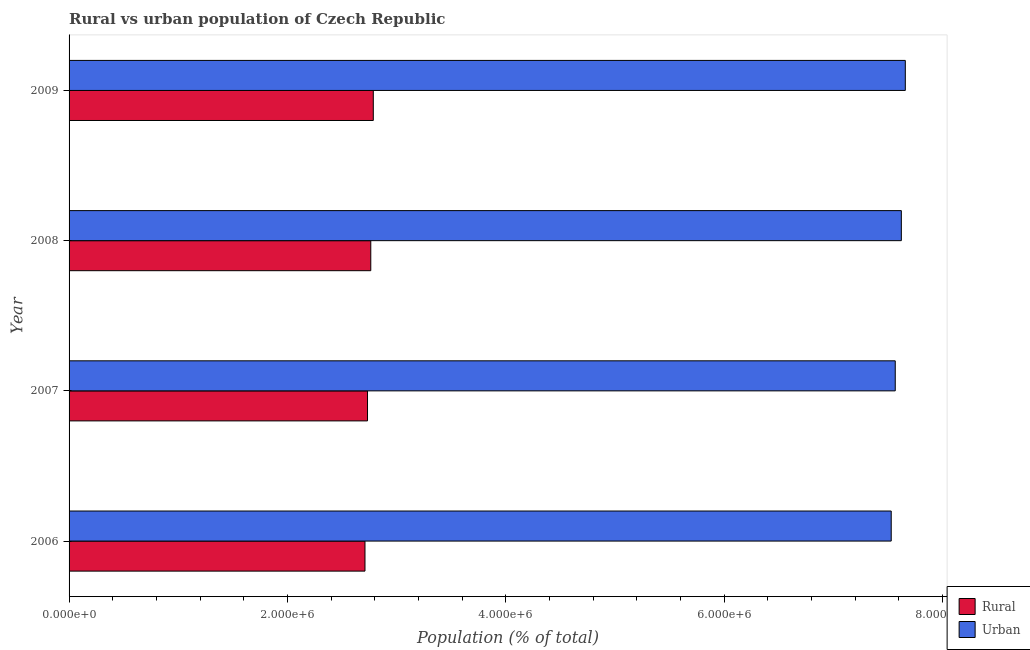How many groups of bars are there?
Provide a succinct answer. 4. How many bars are there on the 4th tick from the top?
Give a very brief answer. 2. How many bars are there on the 3rd tick from the bottom?
Make the answer very short. 2. What is the label of the 2nd group of bars from the top?
Keep it short and to the point. 2008. In how many cases, is the number of bars for a given year not equal to the number of legend labels?
Keep it short and to the point. 0. What is the rural population density in 2009?
Offer a very short reply. 2.79e+06. Across all years, what is the maximum rural population density?
Give a very brief answer. 2.79e+06. Across all years, what is the minimum urban population density?
Your answer should be very brief. 7.53e+06. What is the total rural population density in the graph?
Make the answer very short. 1.10e+07. What is the difference between the rural population density in 2006 and that in 2007?
Your answer should be very brief. -2.31e+04. What is the difference between the rural population density in 2006 and the urban population density in 2007?
Provide a succinct answer. -4.86e+06. What is the average rural population density per year?
Give a very brief answer. 2.75e+06. In the year 2007, what is the difference between the urban population density and rural population density?
Your response must be concise. 4.83e+06. Is the rural population density in 2006 less than that in 2007?
Ensure brevity in your answer.  Yes. What is the difference between the highest and the second highest rural population density?
Keep it short and to the point. 2.31e+04. What is the difference between the highest and the lowest rural population density?
Keep it short and to the point. 7.61e+04. In how many years, is the urban population density greater than the average urban population density taken over all years?
Make the answer very short. 2. What does the 1st bar from the top in 2007 represents?
Keep it short and to the point. Urban. What does the 2nd bar from the bottom in 2008 represents?
Your response must be concise. Urban. What is the difference between two consecutive major ticks on the X-axis?
Provide a succinct answer. 2.00e+06. Does the graph contain grids?
Ensure brevity in your answer.  No. Where does the legend appear in the graph?
Your answer should be very brief. Bottom right. How many legend labels are there?
Your answer should be very brief. 2. How are the legend labels stacked?
Your response must be concise. Vertical. What is the title of the graph?
Your answer should be compact. Rural vs urban population of Czech Republic. What is the label or title of the X-axis?
Make the answer very short. Population (% of total). What is the label or title of the Y-axis?
Offer a very short reply. Year. What is the Population (% of total) of Rural in 2006?
Provide a short and direct response. 2.71e+06. What is the Population (% of total) in Urban in 2006?
Provide a short and direct response. 7.53e+06. What is the Population (% of total) of Rural in 2007?
Your answer should be very brief. 2.73e+06. What is the Population (% of total) in Urban in 2007?
Keep it short and to the point. 7.57e+06. What is the Population (% of total) of Rural in 2008?
Keep it short and to the point. 2.76e+06. What is the Population (% of total) in Urban in 2008?
Your answer should be compact. 7.62e+06. What is the Population (% of total) of Rural in 2009?
Your response must be concise. 2.79e+06. What is the Population (% of total) in Urban in 2009?
Offer a terse response. 7.66e+06. Across all years, what is the maximum Population (% of total) of Rural?
Make the answer very short. 2.79e+06. Across all years, what is the maximum Population (% of total) in Urban?
Provide a short and direct response. 7.66e+06. Across all years, what is the minimum Population (% of total) of Rural?
Your answer should be very brief. 2.71e+06. Across all years, what is the minimum Population (% of total) in Urban?
Give a very brief answer. 7.53e+06. What is the total Population (% of total) of Rural in the graph?
Ensure brevity in your answer.  1.10e+07. What is the total Population (% of total) in Urban in the graph?
Provide a short and direct response. 3.04e+07. What is the difference between the Population (% of total) in Rural in 2006 and that in 2007?
Ensure brevity in your answer.  -2.31e+04. What is the difference between the Population (% of total) in Urban in 2006 and that in 2007?
Your response must be concise. -3.69e+04. What is the difference between the Population (% of total) in Rural in 2006 and that in 2008?
Your response must be concise. -5.30e+04. What is the difference between the Population (% of total) of Urban in 2006 and that in 2008?
Your answer should be very brief. -9.27e+04. What is the difference between the Population (% of total) in Rural in 2006 and that in 2009?
Your response must be concise. -7.61e+04. What is the difference between the Population (% of total) in Urban in 2006 and that in 2009?
Offer a very short reply. -1.29e+05. What is the difference between the Population (% of total) of Rural in 2007 and that in 2008?
Your answer should be compact. -2.99e+04. What is the difference between the Population (% of total) of Urban in 2007 and that in 2008?
Your answer should be compact. -5.58e+04. What is the difference between the Population (% of total) of Rural in 2007 and that in 2009?
Provide a short and direct response. -5.30e+04. What is the difference between the Population (% of total) of Urban in 2007 and that in 2009?
Make the answer very short. -9.21e+04. What is the difference between the Population (% of total) in Rural in 2008 and that in 2009?
Your answer should be very brief. -2.31e+04. What is the difference between the Population (% of total) of Urban in 2008 and that in 2009?
Provide a succinct answer. -3.62e+04. What is the difference between the Population (% of total) of Rural in 2006 and the Population (% of total) of Urban in 2007?
Keep it short and to the point. -4.86e+06. What is the difference between the Population (% of total) in Rural in 2006 and the Population (% of total) in Urban in 2008?
Make the answer very short. -4.91e+06. What is the difference between the Population (% of total) in Rural in 2006 and the Population (% of total) in Urban in 2009?
Offer a terse response. -4.95e+06. What is the difference between the Population (% of total) in Rural in 2007 and the Population (% of total) in Urban in 2008?
Your answer should be very brief. -4.89e+06. What is the difference between the Population (% of total) in Rural in 2007 and the Population (% of total) in Urban in 2009?
Give a very brief answer. -4.92e+06. What is the difference between the Population (% of total) of Rural in 2008 and the Population (% of total) of Urban in 2009?
Make the answer very short. -4.89e+06. What is the average Population (% of total) in Rural per year?
Offer a terse response. 2.75e+06. What is the average Population (% of total) of Urban per year?
Offer a very short reply. 7.59e+06. In the year 2006, what is the difference between the Population (% of total) of Rural and Population (% of total) of Urban?
Your answer should be compact. -4.82e+06. In the year 2007, what is the difference between the Population (% of total) of Rural and Population (% of total) of Urban?
Provide a succinct answer. -4.83e+06. In the year 2008, what is the difference between the Population (% of total) of Rural and Population (% of total) of Urban?
Provide a succinct answer. -4.86e+06. In the year 2009, what is the difference between the Population (% of total) in Rural and Population (% of total) in Urban?
Provide a succinct answer. -4.87e+06. What is the ratio of the Population (% of total) in Urban in 2006 to that in 2007?
Ensure brevity in your answer.  1. What is the ratio of the Population (% of total) of Rural in 2006 to that in 2008?
Your answer should be very brief. 0.98. What is the ratio of the Population (% of total) of Urban in 2006 to that in 2008?
Give a very brief answer. 0.99. What is the ratio of the Population (% of total) in Rural in 2006 to that in 2009?
Your answer should be compact. 0.97. What is the ratio of the Population (% of total) in Urban in 2006 to that in 2009?
Offer a very short reply. 0.98. What is the ratio of the Population (% of total) of Rural in 2007 to that in 2008?
Your answer should be compact. 0.99. What is the ratio of the Population (% of total) in Urban in 2007 to that in 2008?
Your answer should be very brief. 0.99. What is the ratio of the Population (% of total) of Rural in 2007 to that in 2009?
Keep it short and to the point. 0.98. What is the difference between the highest and the second highest Population (% of total) of Rural?
Your answer should be very brief. 2.31e+04. What is the difference between the highest and the second highest Population (% of total) in Urban?
Keep it short and to the point. 3.62e+04. What is the difference between the highest and the lowest Population (% of total) of Rural?
Offer a terse response. 7.61e+04. What is the difference between the highest and the lowest Population (% of total) in Urban?
Keep it short and to the point. 1.29e+05. 